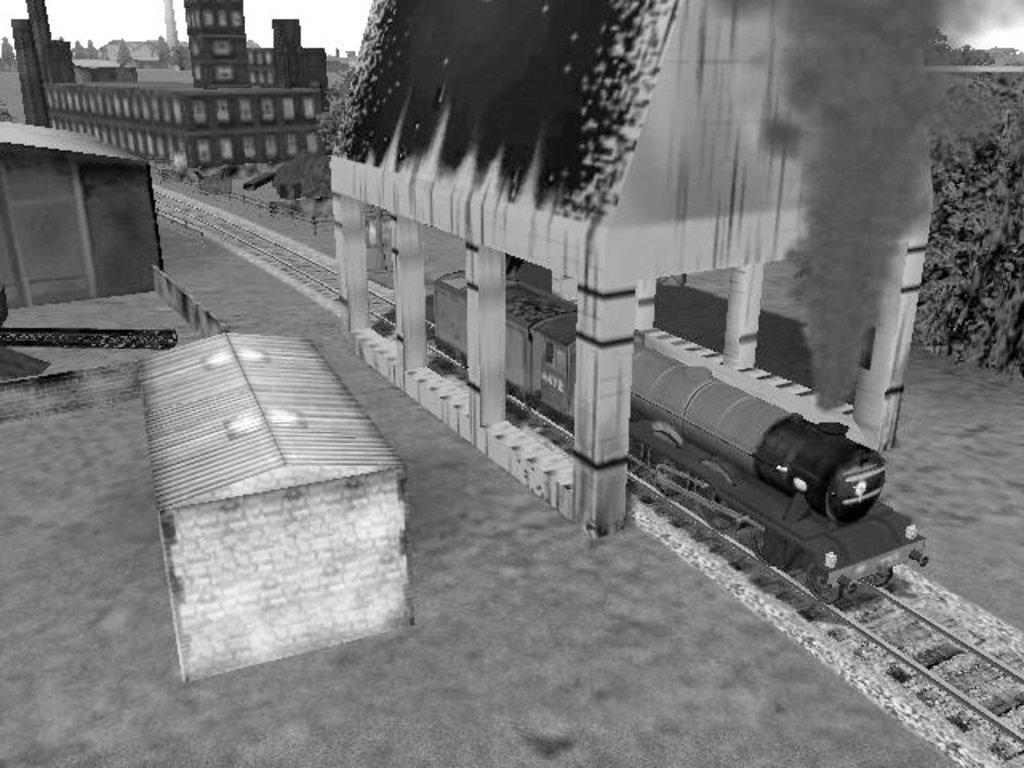How would you summarize this image in a sentence or two? It is a black and white animated image there is a train and behind the train there are few buildings, the train is emitting smoke. 